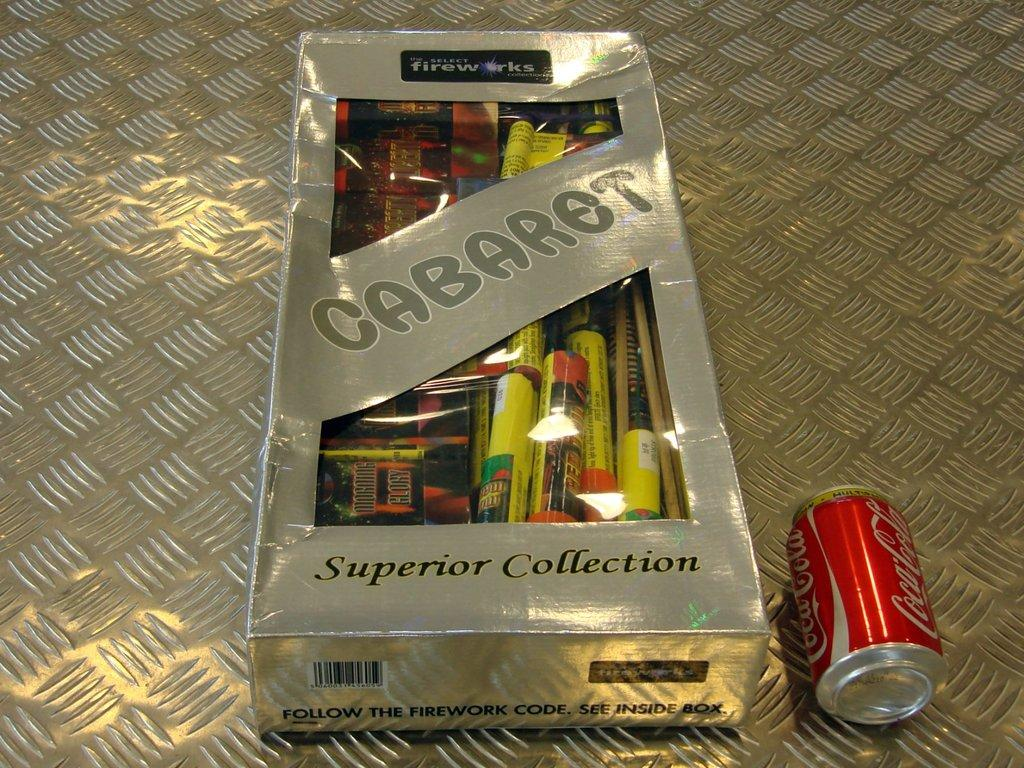<image>
Give a short and clear explanation of the subsequent image. A box of Cabaret fireworks sits on a metal shelf next to a can of soda. 